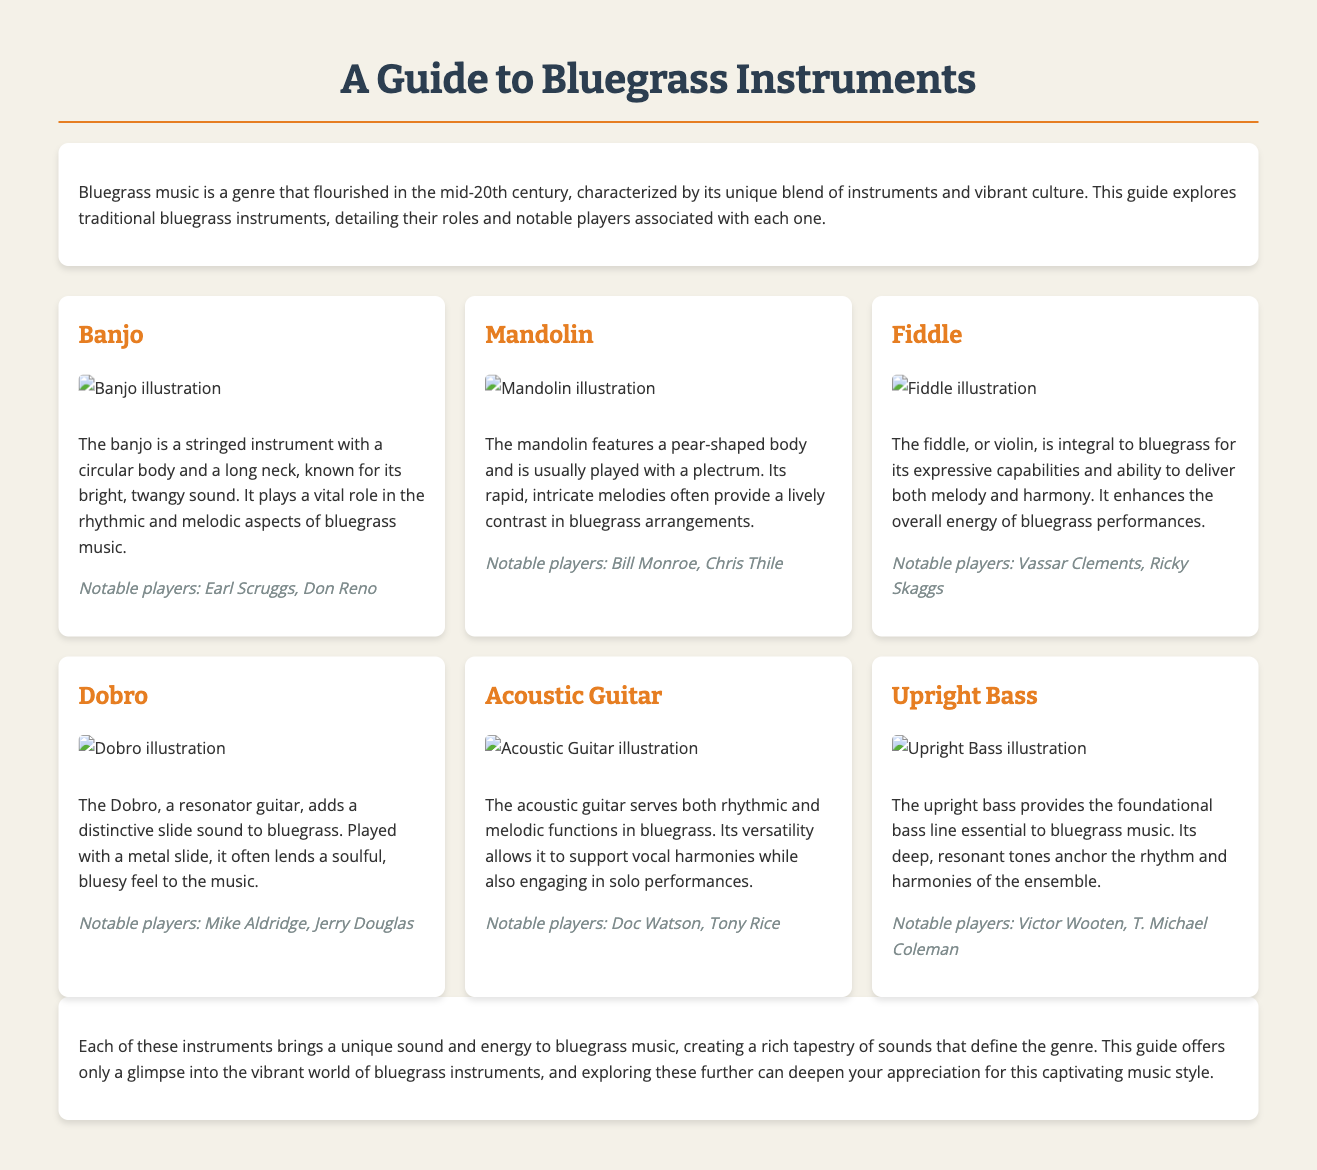What instrument is known for its bright, twangy sound? The banjo is a stringed instrument known for its bright, twangy sound as stated in the document.
Answer: Banjo Who is a notable player associated with the mandolin? The document mentions Bill Monroe as a notable player associated with the mandolin.
Answer: Bill Monroe What role does the upright bass serve in bluegrass music? The upright bass provides the foundational bass line essential to bluegrass music, as indicated in the document.
Answer: Foundational bass line Which instrument is associated with players Mike Aldridge and Jerry Douglas? The document states that Mike Aldridge and Jerry Douglas are notable players associated with the Dobro.
Answer: Dobro What is a characteristic sound created by the Dobro? The document explains that the Dobro adds a distinctive slide sound to bluegrass.
Answer: Distinctive slide sound How many instruments are detailed in the guide? The guide details six traditional bluegrass instruments.
Answer: Six What are the two main functions of the acoustic guitar in bluegrass? The document mentions that the acoustic guitar serves both rhythmic and melodic functions in bluegrass music.
Answer: Rhythmic and melodic functions What instrument enhances the overall energy of bluegrass performances? The fiddle enhances the overall energy of bluegrass performances, as stated in the document.
Answer: Fiddle Who are the notable players associated with the banjo? The document lists Earl Scruggs and Don Reno as notable players associated with the banjo.
Answer: Earl Scruggs, Don Reno 